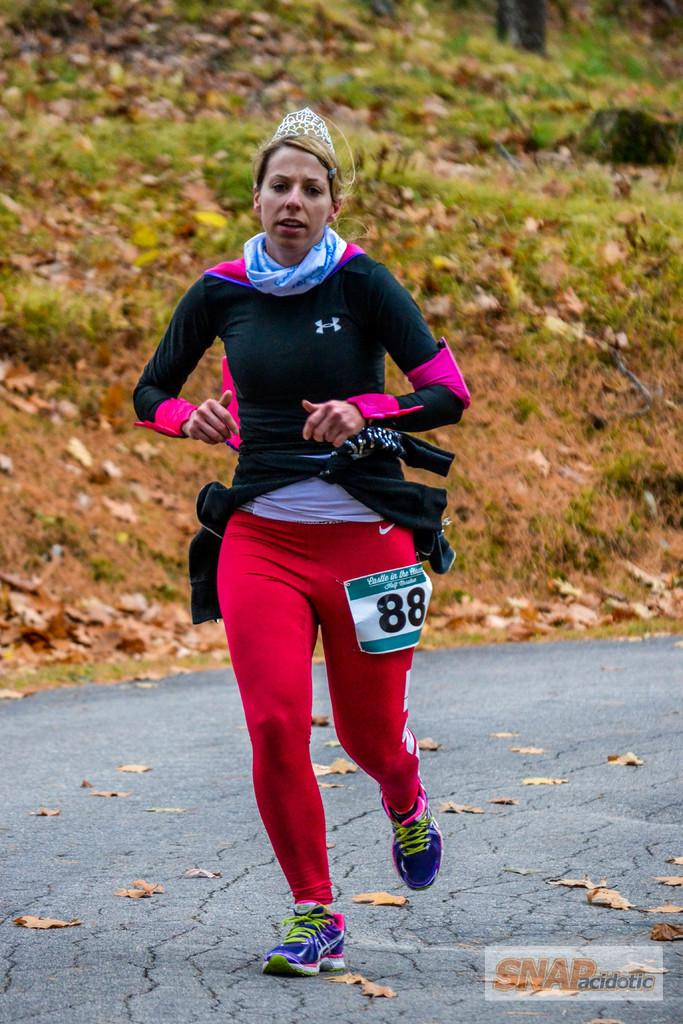What is the person in the image doing? The person is running in the image. Where is the person running? The person is on the road. What can be seen in the background of the image? There are leaves and grass in the background of the image. What is written at the bottom of the image? There is a text written on a poster at the bottom of the image. What unit of measurement is used to determine the depth of the tub in the image? There is no tub present in the image, so it is not possible to determine the unit of measurement used for its depth. 